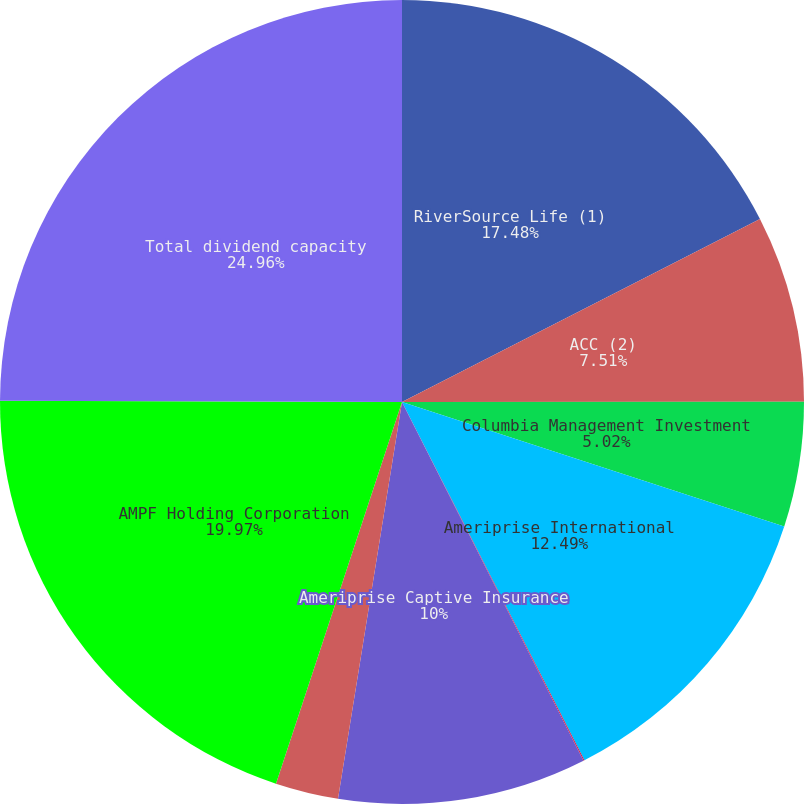<chart> <loc_0><loc_0><loc_500><loc_500><pie_chart><fcel>RiverSource Life (1)<fcel>ACC (2)<fcel>Columbia Management Investment<fcel>Ameriprise International<fcel>Ameriprise Trust Company<fcel>Ameriprise Captive Insurance<fcel>RiverSource Distributors Inc<fcel>AMPF Holding Corporation<fcel>Total dividend capacity<nl><fcel>17.48%<fcel>7.51%<fcel>5.02%<fcel>12.49%<fcel>0.04%<fcel>10.0%<fcel>2.53%<fcel>19.97%<fcel>24.95%<nl></chart> 